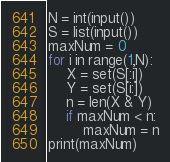<code> <loc_0><loc_0><loc_500><loc_500><_Python_>N = int(input())
S = list(input())
maxNum = 0
for i in range(1,N):
    X = set(S[:i])
    Y = set(S[i:])
    n = len(X & Y)
    if maxNum < n:
        maxNum = n
print(maxNum)</code> 